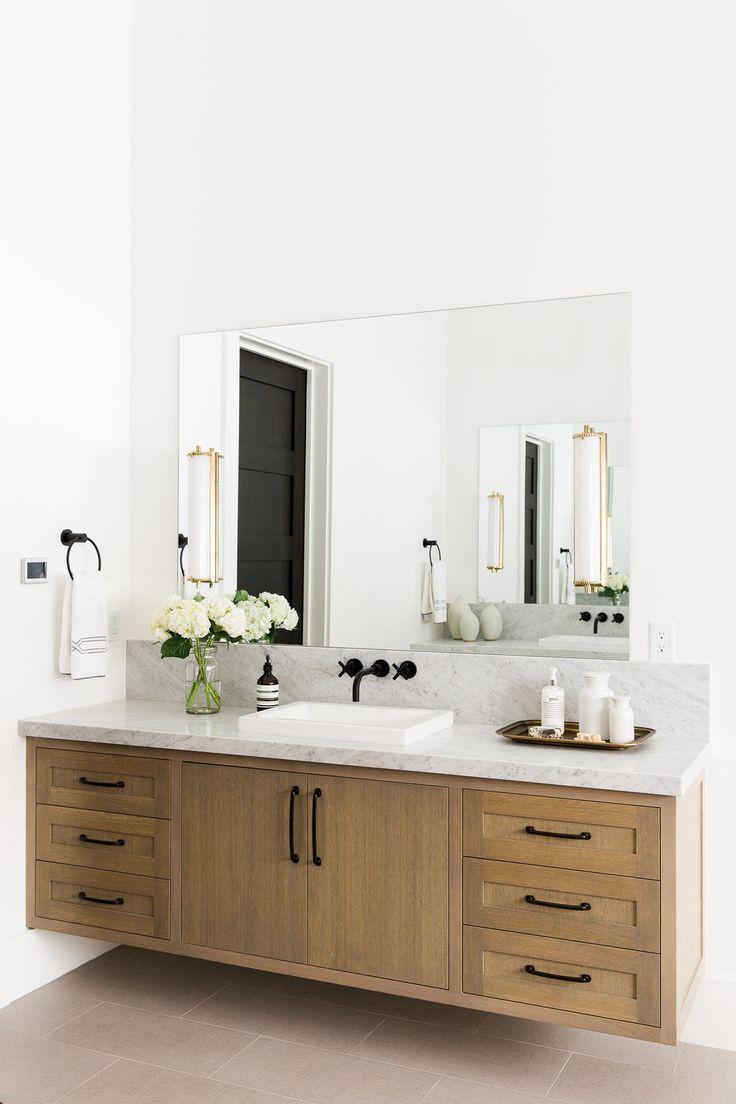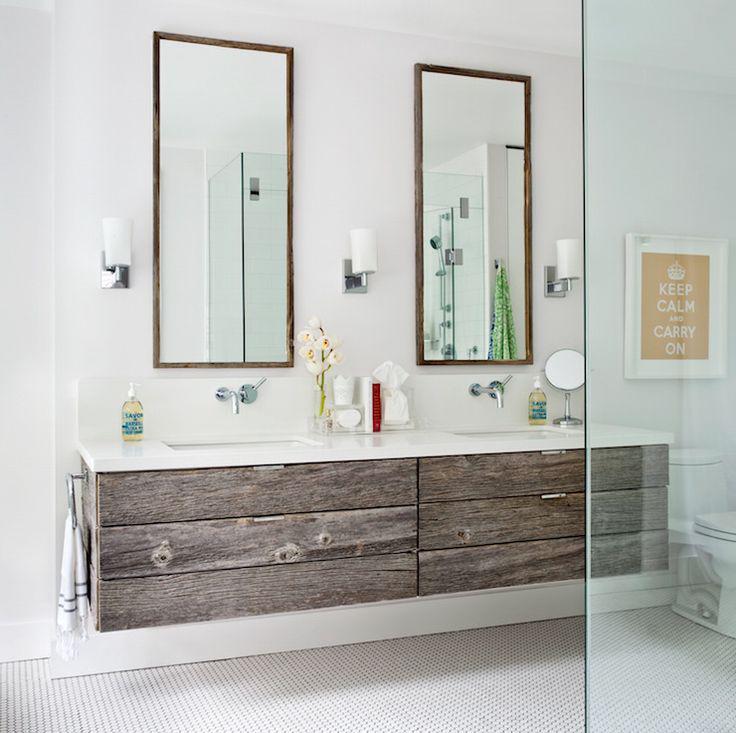The first image is the image on the left, the second image is the image on the right. Given the left and right images, does the statement "One of the sinks has no drawers attached to it." hold true? Answer yes or no. No. The first image is the image on the left, the second image is the image on the right. Given the left and right images, does the statement "Both image show a sink and vanity, but only one image has a rectangular sink basin." hold true? Answer yes or no. No. 